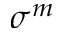<formula> <loc_0><loc_0><loc_500><loc_500>\sigma ^ { m }</formula> 